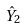Convert formula to latex. <formula><loc_0><loc_0><loc_500><loc_500>\hat { Y } _ { 2 }</formula> 